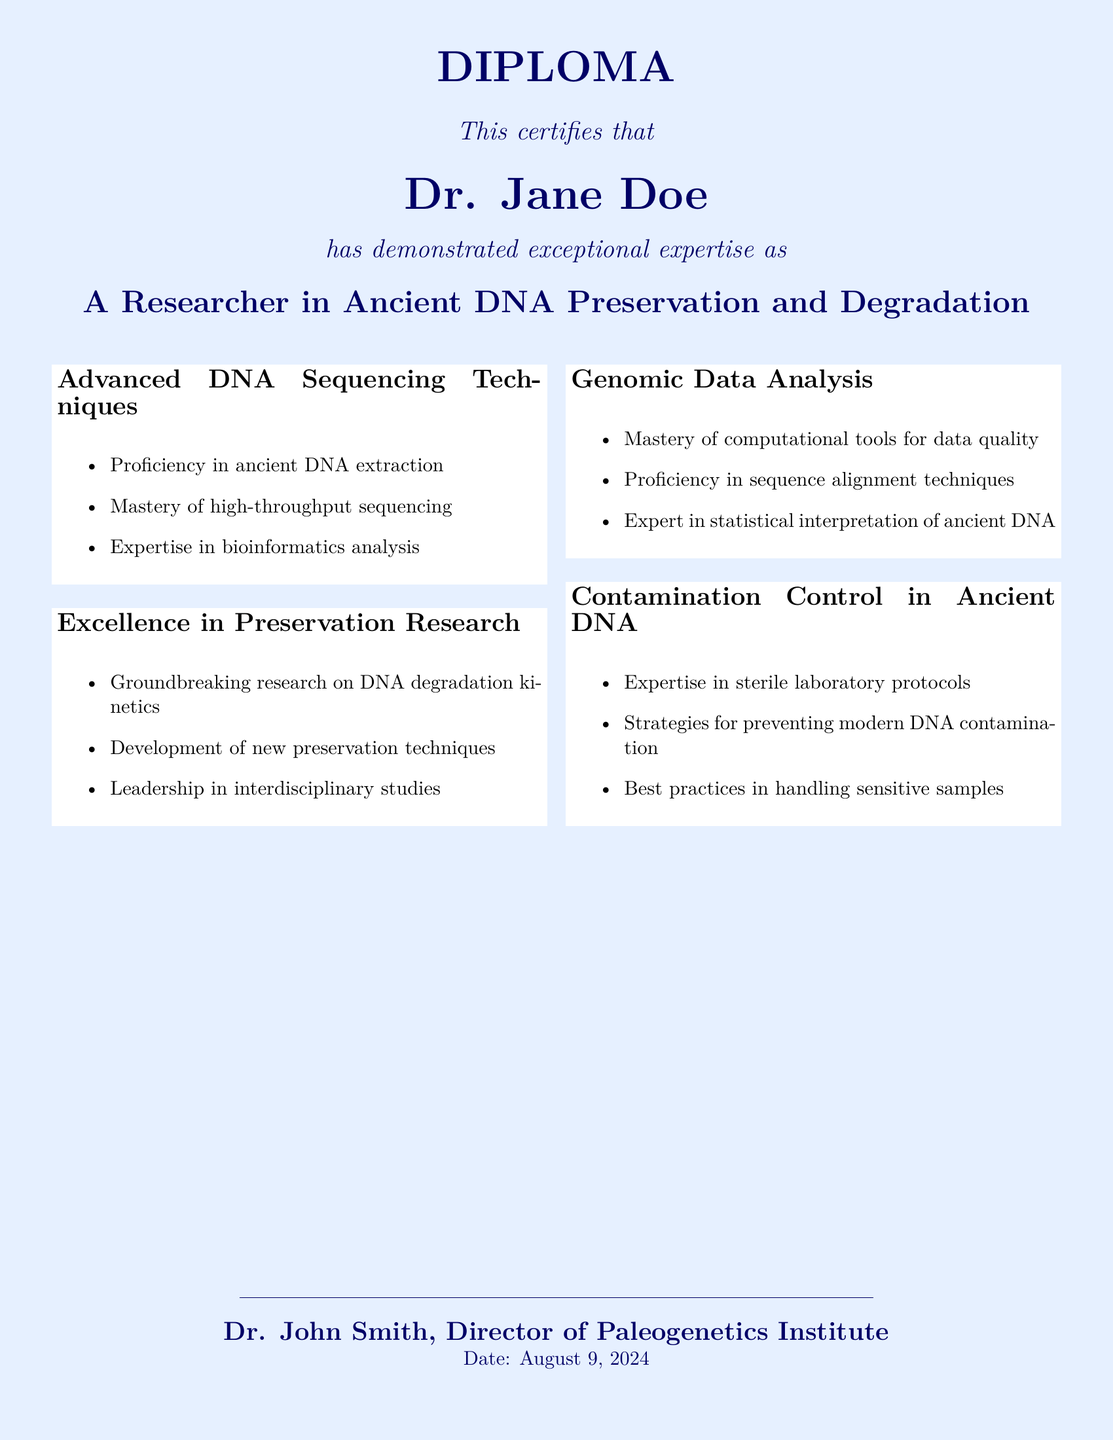What is the name of the individual receiving the diploma? The name is prominently displayed at the center of the diploma, confirming the recipient's identity.
Answer: Dr. Jane Doe What year was the Advanced DNA Sequencing Techniques Course completed? The document states the certification is for the year 2023.
Answer: 2023 What is one area of proficiency listed under Advanced DNA Sequencing Techniques? The document lists multiple proficiencies, focusing on one area of expertise detailed within the achievement section.
Answer: Ancient DNA extraction What significant research topic is highlighted in the Excellence in Preservation Research section? The document mentions significant contributions, emphasizing key areas such as DNA degradation kinetics within the research context.
Answer: DNA degradation kinetics Who is the director of the Paleogenetics Institute? The signature section explicitly identifies the director associated with the issuance of the diploma, confirming the leadership behind the institute.
Answer: Dr. John Smith How many competencies are covered in the Genomic Data Analysis section? The document clearly outlines the competencies, breaking them down into a complete list specified under the Genomic Data Analysis achievement.
Answer: Three What type of training is mentioned in the Contamination Control in Ancient DNA section? The document mentions specific training that is categorized and focuses on practical applications within the field of contamination control.
Answer: Hands-on training What is the overall theme of the diploma? The diploma encompasses a theme that emphasizes the recipient's achievements and qualifications in the specialized field of ancient DNA preservation and degradation.
Answer: Ancient DNA Preservation and Degradation What is one of the topics discussed at the International Symposium on Paleogenetics? The document lists topics discussed in the symposium, highlighting major areas of focus within paleogenetics research.
Answer: Emerging technologies in ancient DNA recovery 